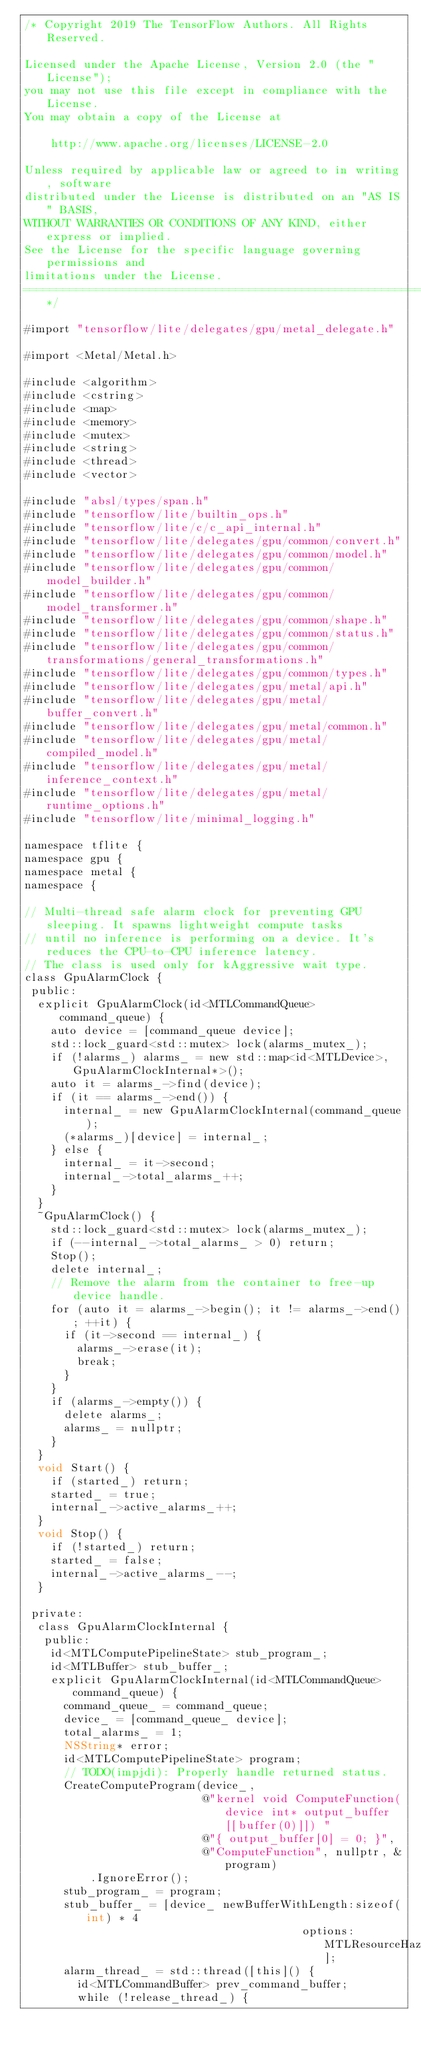Convert code to text. <code><loc_0><loc_0><loc_500><loc_500><_ObjectiveC_>/* Copyright 2019 The TensorFlow Authors. All Rights Reserved.

Licensed under the Apache License, Version 2.0 (the "License");
you may not use this file except in compliance with the License.
You may obtain a copy of the License at

    http://www.apache.org/licenses/LICENSE-2.0

Unless required by applicable law or agreed to in writing, software
distributed under the License is distributed on an "AS IS" BASIS,
WITHOUT WARRANTIES OR CONDITIONS OF ANY KIND, either express or implied.
See the License for the specific language governing permissions and
limitations under the License.
==============================================================================*/

#import "tensorflow/lite/delegates/gpu/metal_delegate.h"

#import <Metal/Metal.h>

#include <algorithm>
#include <cstring>
#include <map>
#include <memory>
#include <mutex>
#include <string>
#include <thread>
#include <vector>

#include "absl/types/span.h"
#include "tensorflow/lite/builtin_ops.h"
#include "tensorflow/lite/c/c_api_internal.h"
#include "tensorflow/lite/delegates/gpu/common/convert.h"
#include "tensorflow/lite/delegates/gpu/common/model.h"
#include "tensorflow/lite/delegates/gpu/common/model_builder.h"
#include "tensorflow/lite/delegates/gpu/common/model_transformer.h"
#include "tensorflow/lite/delegates/gpu/common/shape.h"
#include "tensorflow/lite/delegates/gpu/common/status.h"
#include "tensorflow/lite/delegates/gpu/common/transformations/general_transformations.h"
#include "tensorflow/lite/delegates/gpu/common/types.h"
#include "tensorflow/lite/delegates/gpu/metal/api.h"
#include "tensorflow/lite/delegates/gpu/metal/buffer_convert.h"
#include "tensorflow/lite/delegates/gpu/metal/common.h"
#include "tensorflow/lite/delegates/gpu/metal/compiled_model.h"
#include "tensorflow/lite/delegates/gpu/metal/inference_context.h"
#include "tensorflow/lite/delegates/gpu/metal/runtime_options.h"
#include "tensorflow/lite/minimal_logging.h"

namespace tflite {
namespace gpu {
namespace metal {
namespace {

// Multi-thread safe alarm clock for preventing GPU sleeping. It spawns lightweight compute tasks
// until no inference is performing on a device. It's reduces the CPU-to-CPU inference latency.
// The class is used only for kAggressive wait type.
class GpuAlarmClock {
 public:
  explicit GpuAlarmClock(id<MTLCommandQueue> command_queue) {
    auto device = [command_queue device];
    std::lock_guard<std::mutex> lock(alarms_mutex_);
    if (!alarms_) alarms_ = new std::map<id<MTLDevice>, GpuAlarmClockInternal*>();
    auto it = alarms_->find(device);
    if (it == alarms_->end()) {
      internal_ = new GpuAlarmClockInternal(command_queue);
      (*alarms_)[device] = internal_;
    } else {
      internal_ = it->second;
      internal_->total_alarms_++;
    }
  }
  ~GpuAlarmClock() {
    std::lock_guard<std::mutex> lock(alarms_mutex_);
    if (--internal_->total_alarms_ > 0) return;
    Stop();
    delete internal_;
    // Remove the alarm from the container to free-up device handle.
    for (auto it = alarms_->begin(); it != alarms_->end(); ++it) {
      if (it->second == internal_) {
        alarms_->erase(it);
        break;
      }
    }
    if (alarms_->empty()) {
      delete alarms_;
      alarms_ = nullptr;
    }
  }
  void Start() {
    if (started_) return;
    started_ = true;
    internal_->active_alarms_++;
  }
  void Stop() {
    if (!started_) return;
    started_ = false;
    internal_->active_alarms_--;
  }

 private:
  class GpuAlarmClockInternal {
   public:
    id<MTLComputePipelineState> stub_program_;
    id<MTLBuffer> stub_buffer_;
    explicit GpuAlarmClockInternal(id<MTLCommandQueue> command_queue) {
      command_queue_ = command_queue;
      device_ = [command_queue_ device];
      total_alarms_ = 1;
      NSString* error;
      id<MTLComputePipelineState> program;
      // TODO(impjdi): Properly handle returned status.
      CreateComputeProgram(device_,
                           @"kernel void ComputeFunction(device int* output_buffer [[buffer(0)]]) "
                           @"{ output_buffer[0] = 0; }",
                           @"ComputeFunction", nullptr, &program)
          .IgnoreError();
      stub_program_ = program;
      stub_buffer_ = [device_ newBufferWithLength:sizeof(int) * 4
                                          options:MTLResourceHazardTrackingModeUntracked];
      alarm_thread_ = std::thread([this]() {
        id<MTLCommandBuffer> prev_command_buffer;
        while (!release_thread_) {</code> 